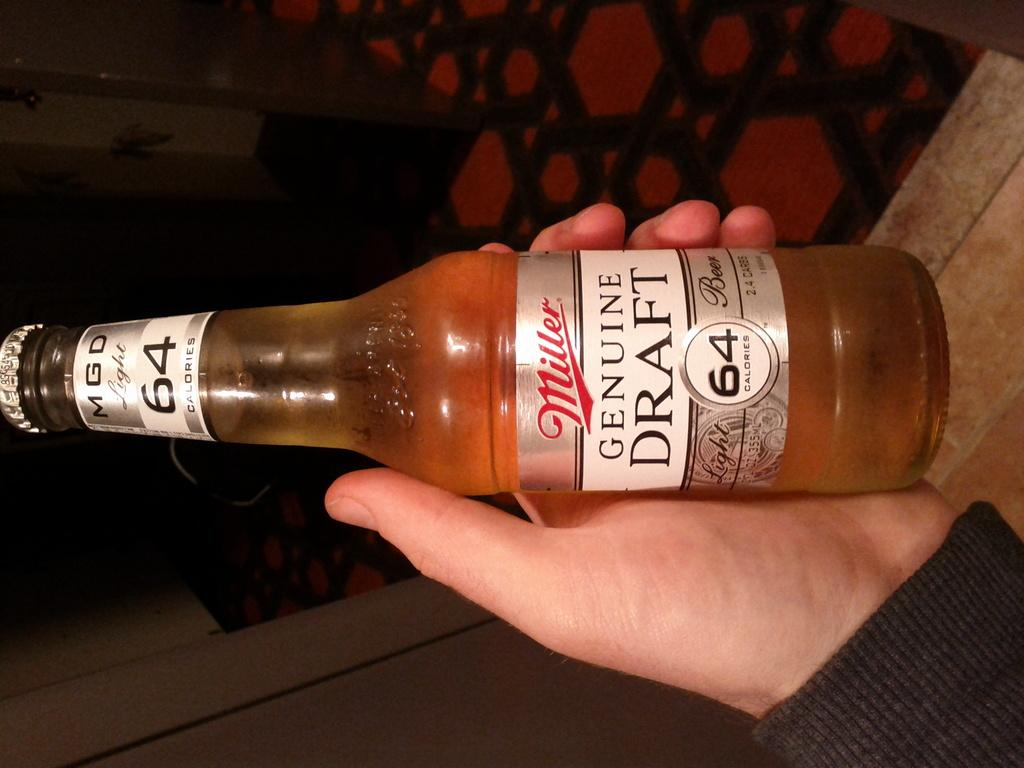<image>
Offer a succinct explanation of the picture presented. a bottle of Miller beer with Genuine Draft 64 written on the label 